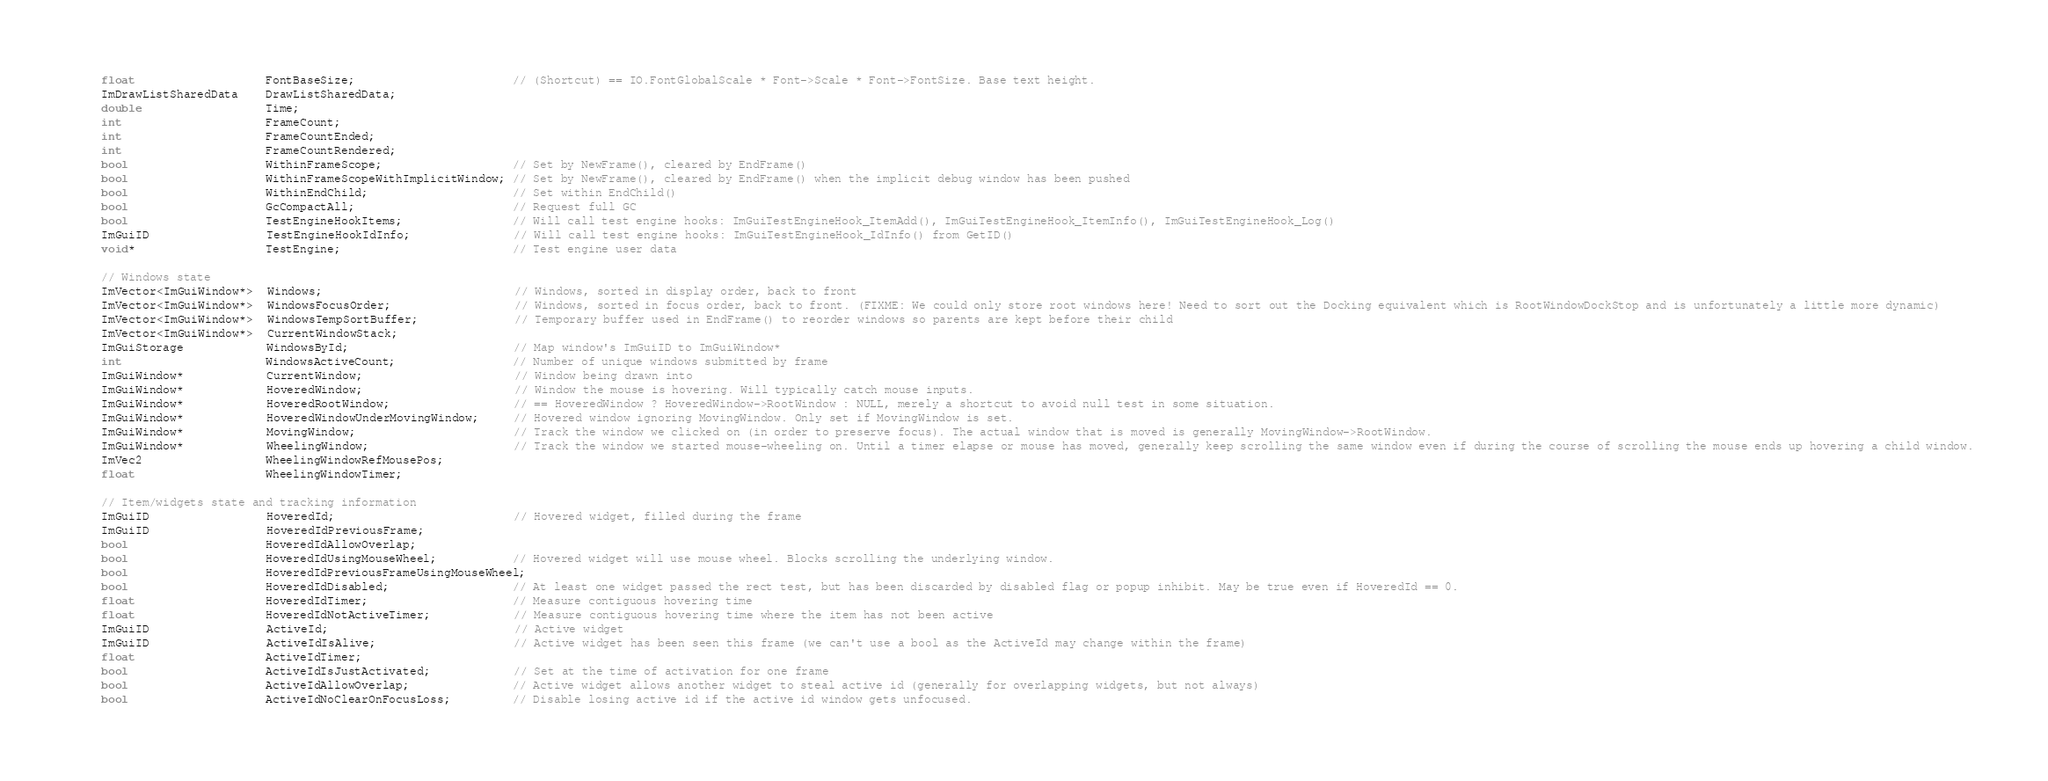<code> <loc_0><loc_0><loc_500><loc_500><_C_>    float                   FontBaseSize;                       // (Shortcut) == IO.FontGlobalScale * Font->Scale * Font->FontSize. Base text height.
    ImDrawListSharedData    DrawListSharedData;
    double                  Time;
    int                     FrameCount;
    int                     FrameCountEnded;
    int                     FrameCountRendered;
    bool                    WithinFrameScope;                   // Set by NewFrame(), cleared by EndFrame()
    bool                    WithinFrameScopeWithImplicitWindow; // Set by NewFrame(), cleared by EndFrame() when the implicit debug window has been pushed
    bool                    WithinEndChild;                     // Set within EndChild()
    bool                    GcCompactAll;                       // Request full GC
    bool                    TestEngineHookItems;                // Will call test engine hooks: ImGuiTestEngineHook_ItemAdd(), ImGuiTestEngineHook_ItemInfo(), ImGuiTestEngineHook_Log()
    ImGuiID                 TestEngineHookIdInfo;               // Will call test engine hooks: ImGuiTestEngineHook_IdInfo() from GetID()
    void*                   TestEngine;                         // Test engine user data

    // Windows state
    ImVector<ImGuiWindow*>  Windows;                            // Windows, sorted in display order, back to front
    ImVector<ImGuiWindow*>  WindowsFocusOrder;                  // Windows, sorted in focus order, back to front. (FIXME: We could only store root windows here! Need to sort out the Docking equivalent which is RootWindowDockStop and is unfortunately a little more dynamic)
    ImVector<ImGuiWindow*>  WindowsTempSortBuffer;              // Temporary buffer used in EndFrame() to reorder windows so parents are kept before their child
    ImVector<ImGuiWindow*>  CurrentWindowStack;
    ImGuiStorage            WindowsById;                        // Map window's ImGuiID to ImGuiWindow*
    int                     WindowsActiveCount;                 // Number of unique windows submitted by frame
    ImGuiWindow*            CurrentWindow;                      // Window being drawn into
    ImGuiWindow*            HoveredWindow;                      // Window the mouse is hovering. Will typically catch mouse inputs.
    ImGuiWindow*            HoveredRootWindow;                  // == HoveredWindow ? HoveredWindow->RootWindow : NULL, merely a shortcut to avoid null test in some situation.
    ImGuiWindow*            HoveredWindowUnderMovingWindow;     // Hovered window ignoring MovingWindow. Only set if MovingWindow is set.
    ImGuiWindow*            MovingWindow;                       // Track the window we clicked on (in order to preserve focus). The actual window that is moved is generally MovingWindow->RootWindow.
    ImGuiWindow*            WheelingWindow;                     // Track the window we started mouse-wheeling on. Until a timer elapse or mouse has moved, generally keep scrolling the same window even if during the course of scrolling the mouse ends up hovering a child window.
    ImVec2                  WheelingWindowRefMousePos;
    float                   WheelingWindowTimer;

    // Item/widgets state and tracking information
    ImGuiID                 HoveredId;                          // Hovered widget, filled during the frame
    ImGuiID                 HoveredIdPreviousFrame;
    bool                    HoveredIdAllowOverlap;
    bool                    HoveredIdUsingMouseWheel;           // Hovered widget will use mouse wheel. Blocks scrolling the underlying window.
    bool                    HoveredIdPreviousFrameUsingMouseWheel;
    bool                    HoveredIdDisabled;                  // At least one widget passed the rect test, but has been discarded by disabled flag or popup inhibit. May be true even if HoveredId == 0.
    float                   HoveredIdTimer;                     // Measure contiguous hovering time
    float                   HoveredIdNotActiveTimer;            // Measure contiguous hovering time where the item has not been active
    ImGuiID                 ActiveId;                           // Active widget
    ImGuiID                 ActiveIdIsAlive;                    // Active widget has been seen this frame (we can't use a bool as the ActiveId may change within the frame)
    float                   ActiveIdTimer;
    bool                    ActiveIdIsJustActivated;            // Set at the time of activation for one frame
    bool                    ActiveIdAllowOverlap;               // Active widget allows another widget to steal active id (generally for overlapping widgets, but not always)
    bool                    ActiveIdNoClearOnFocusLoss;         // Disable losing active id if the active id window gets unfocused.</code> 